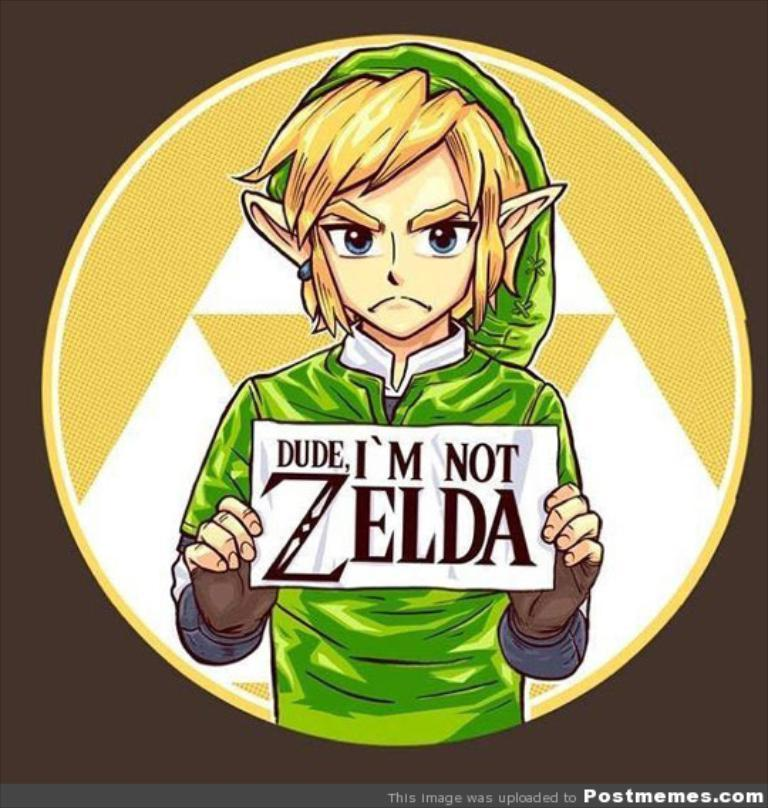<image>
Write a terse but informative summary of the picture. a character holding a sign that says I am not Zelda 